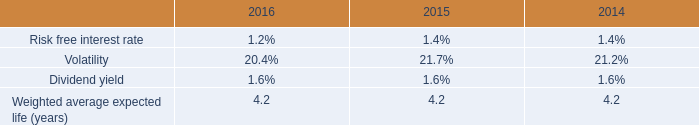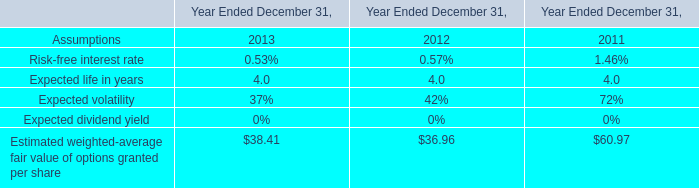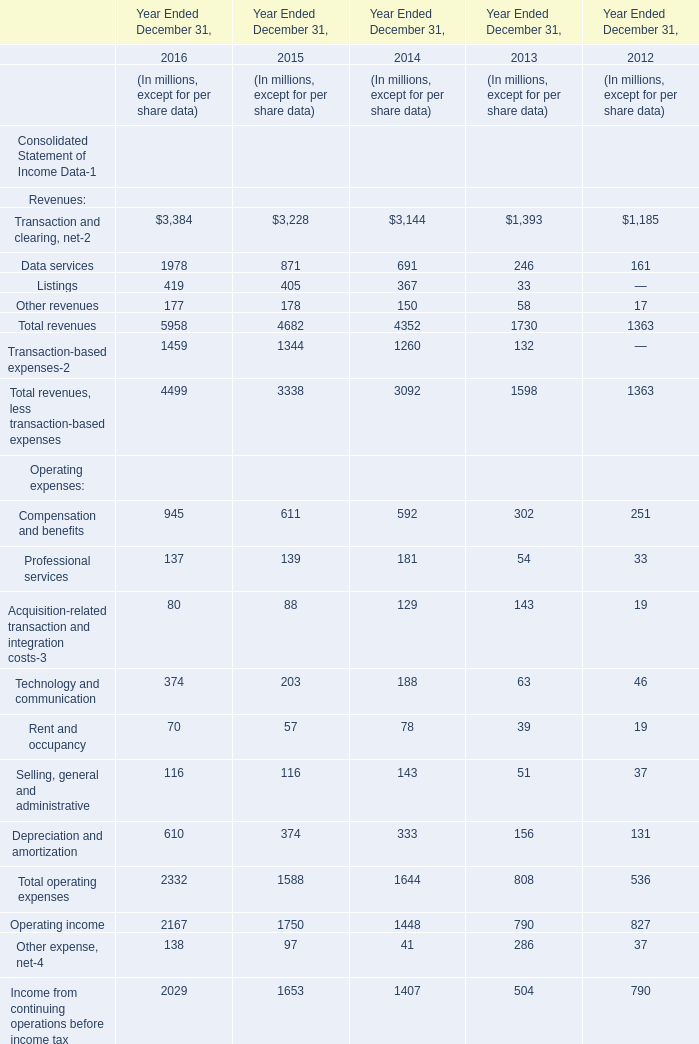what was the difference in millions of the accumulated benefit obligation as of december 31 , 2016 versus the projected benefit obligation? 
Computations: (49 - 50)
Answer: -1.0. 